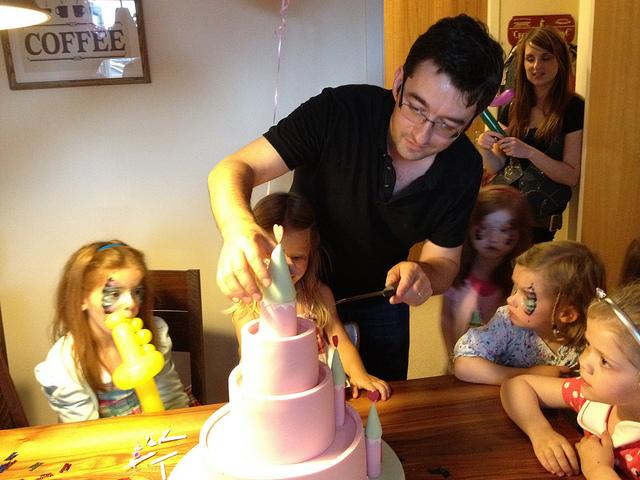Where was the castle themed birthday cake most likely created? Please explain your reasoning. bakery. Cakes are made in bakeries. 